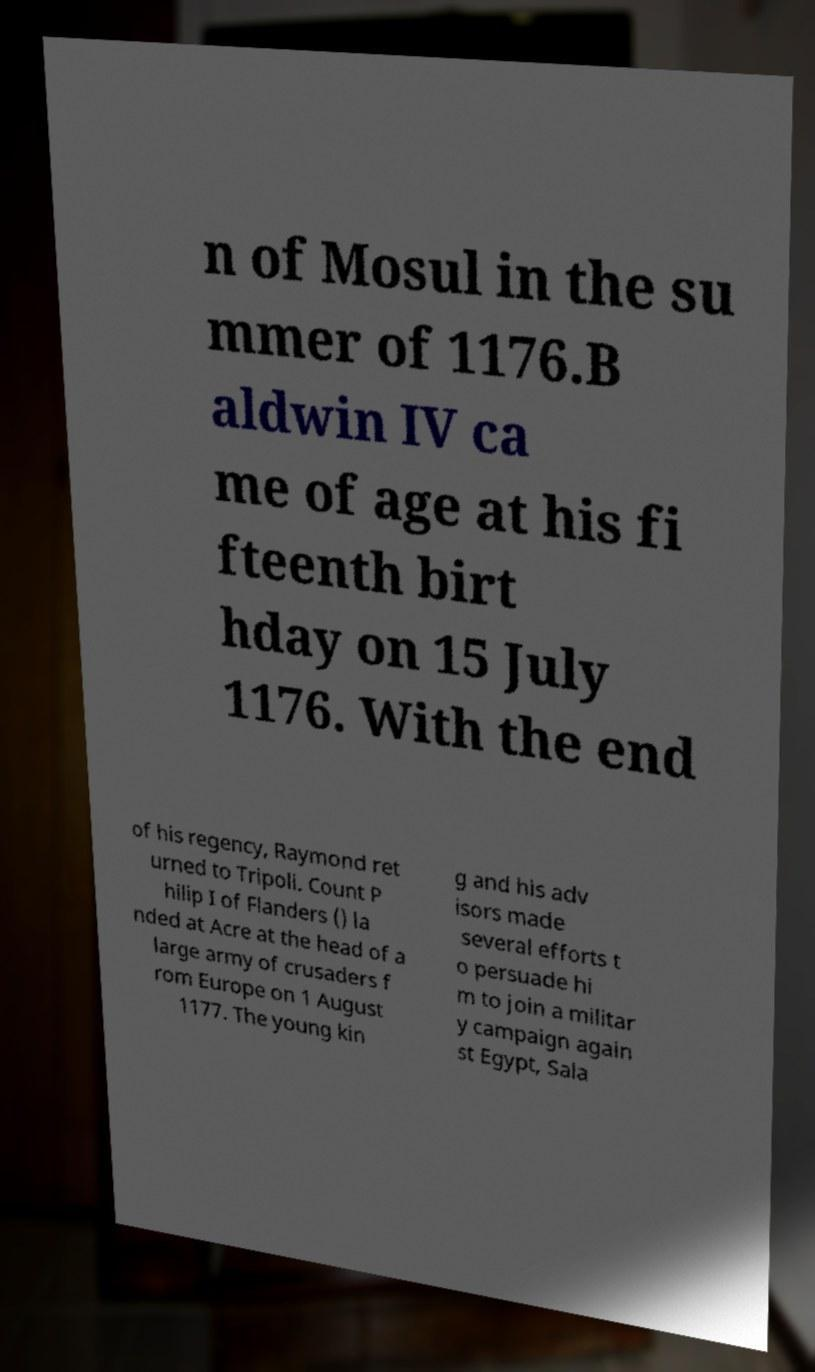Please read and relay the text visible in this image. What does it say? n of Mosul in the su mmer of 1176.B aldwin IV ca me of age at his fi fteenth birt hday on 15 July 1176. With the end of his regency, Raymond ret urned to Tripoli. Count P hilip I of Flanders () la nded at Acre at the head of a large army of crusaders f rom Europe on 1 August 1177. The young kin g and his adv isors made several efforts t o persuade hi m to join a militar y campaign again st Egypt, Sala 